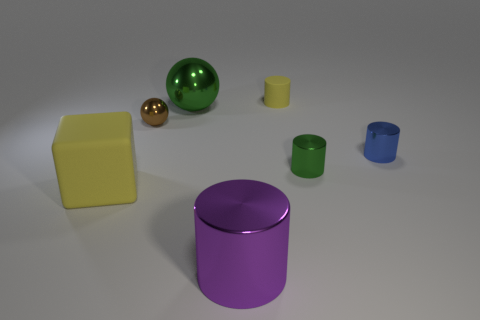Subtract all green metal cylinders. How many cylinders are left? 3 Add 2 big purple metal objects. How many objects exist? 9 Subtract all purple cylinders. How many cylinders are left? 3 Subtract all balls. How many objects are left? 5 Subtract all blue cylinders. Subtract all purple spheres. How many cylinders are left? 3 Add 2 green matte spheres. How many green matte spheres exist? 2 Subtract 0 gray blocks. How many objects are left? 7 Subtract all tiny yellow objects. Subtract all cubes. How many objects are left? 5 Add 4 large green things. How many large green things are left? 5 